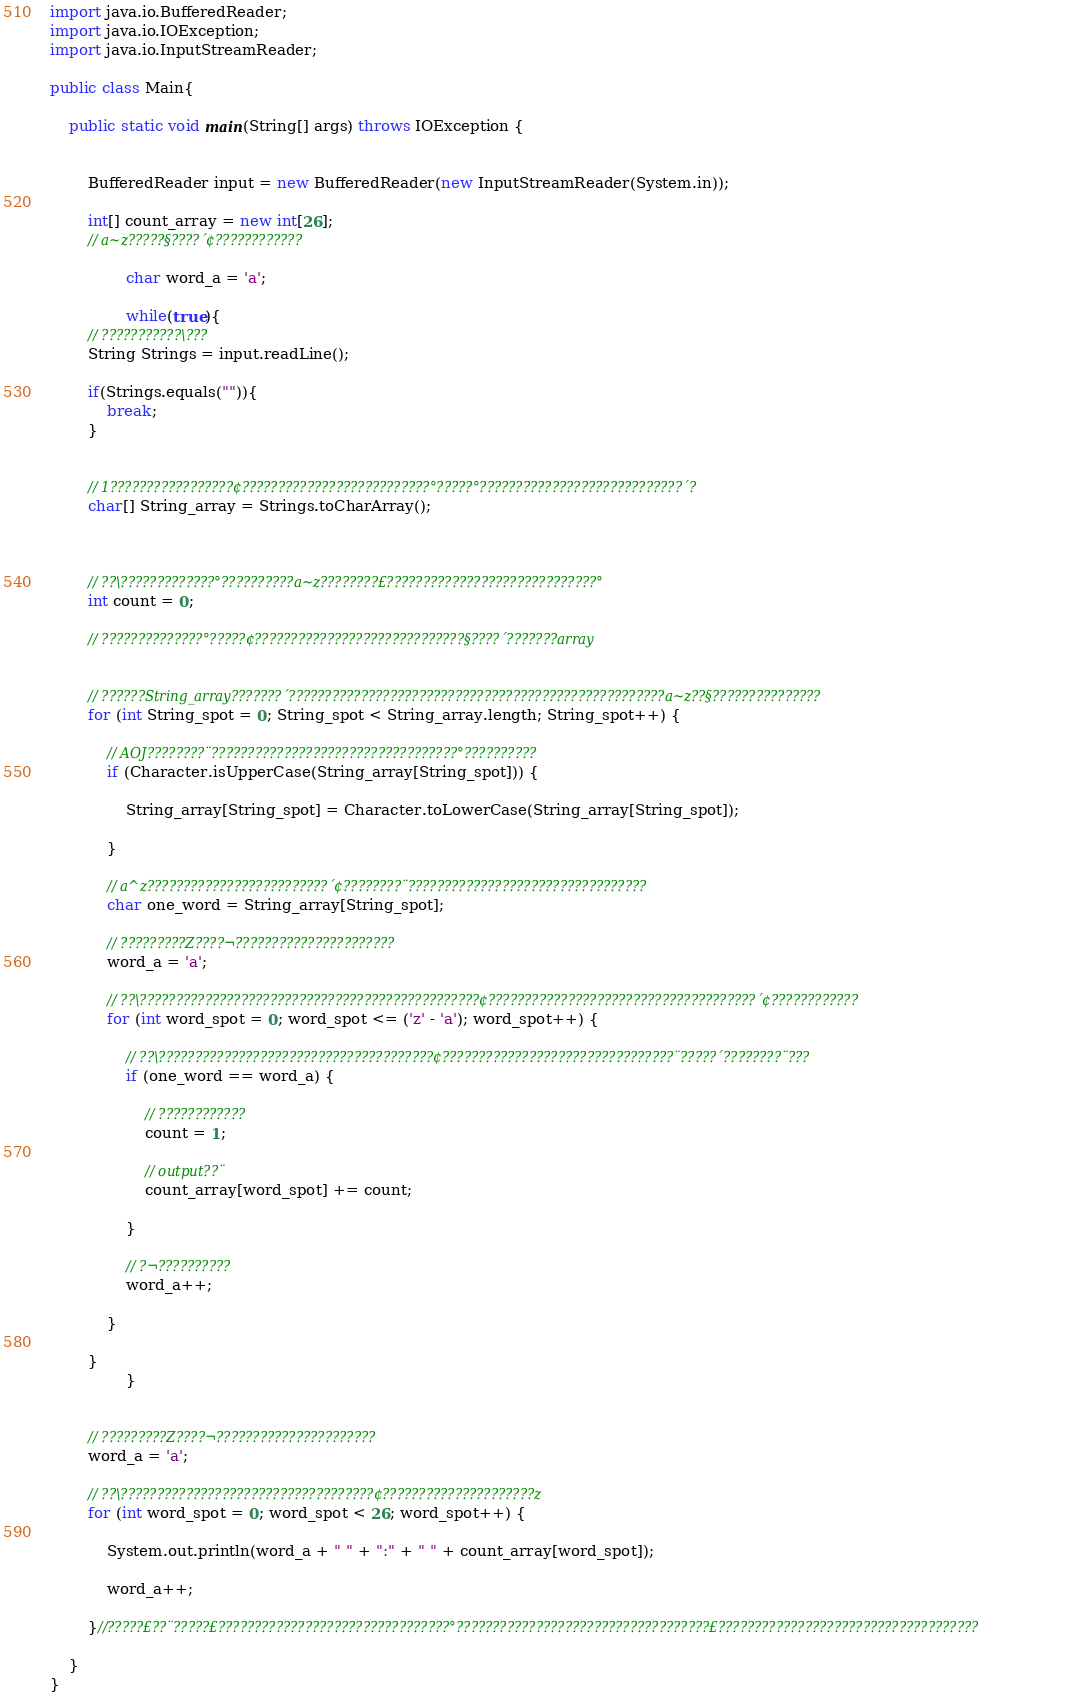<code> <loc_0><loc_0><loc_500><loc_500><_Java_>import java.io.BufferedReader;
import java.io.IOException;
import java.io.InputStreamReader;

public class Main{

	public static void main(String[] args) throws IOException {


		BufferedReader input = new BufferedReader(new InputStreamReader(System.in));

		int[] count_array = new int[26];
		// a~z?????§????´¢????????????

				char word_a = 'a';

				while(true){
		// ???????????\???
		String Strings = input.readLine();

		if(Strings.equals("")){
			break;
		}


		// 1?????????????????¢??????????????????????????°?????°????????????????????????????´?
		char[] String_array = Strings.toCharArray();



		// ??\?????????????°??????????a~z????????£?????????????????????????????°
		int count = 0;

		// ??????????????°?????¢?????????????????????????????§????´???????array


		// ??????String_array???????´????????????????????????????????????????????????????a~z??§???????????????
		for (int String_spot = 0; String_spot < String_array.length; String_spot++) {

			// AOJ????????¨??????????????????????????????????°??????????
			if (Character.isUpperCase(String_array[String_spot])) {

				String_array[String_spot] = Character.toLowerCase(String_array[String_spot]);

			}

			// a^z?????????????????????????´¢????????¨?????????????????????????????????
			char one_word = String_array[String_spot];

			// ?????????Z????¬??????????????????????
			word_a = 'a';

			// ??\???????????????????????????????????????????????¢?????????????????????????????????????´¢????????????
			for (int word_spot = 0; word_spot <= ('z' - 'a'); word_spot++) {

				// ??\??????????????????????????????????????¢????????????????????????????????¨?????´????????¨???
				if (one_word == word_a) {

					// ????????????
					count = 1;

					// output??¨
					count_array[word_spot] += count;

				}

				// ?¬??????????
				word_a++;

			}

		}
				}


		// ?????????Z????¬??????????????????????
		word_a = 'a';

		// ??\???????????????????????????????????¢?????????????????????z
		for (int word_spot = 0; word_spot < 26; word_spot++) {

			System.out.println(word_a + " " + ":" + " " + count_array[word_spot]);

			word_a++;

		}//?????£??¨?????£????????????????????????????????°???????????????????????????????????£????????????????????????????????????

	}
}</code> 